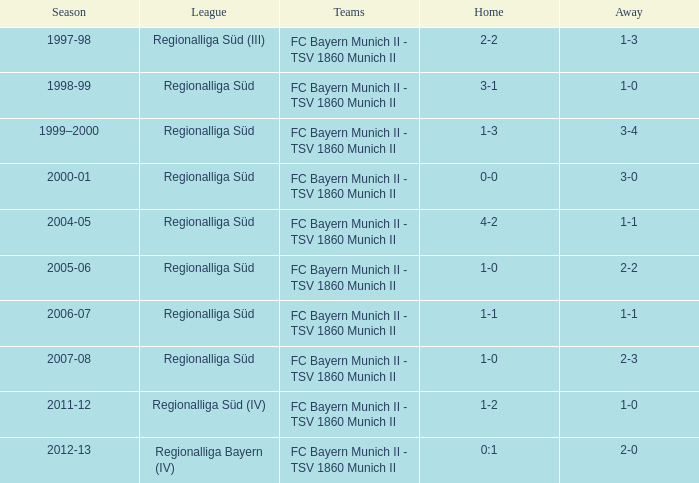What league has a 3-1 home? Regionalliga Süd. 